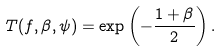Convert formula to latex. <formula><loc_0><loc_0><loc_500><loc_500>T ( f , \beta , \psi ) = \exp \left ( - \frac { 1 + \beta } { 2 } \right ) .</formula> 